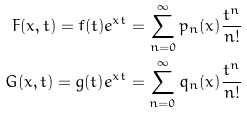Convert formula to latex. <formula><loc_0><loc_0><loc_500><loc_500>F ( x , t ) = f ( t ) e ^ { x t } = \sum _ { n = 0 } ^ { \infty } p _ { n } ( x ) \frac { t ^ { n } } { n ! } \\ G ( x , t ) = g ( t ) e ^ { x t } = \sum _ { n = 0 } ^ { \infty } q _ { n } ( x ) \frac { t ^ { n } } { n ! }</formula> 